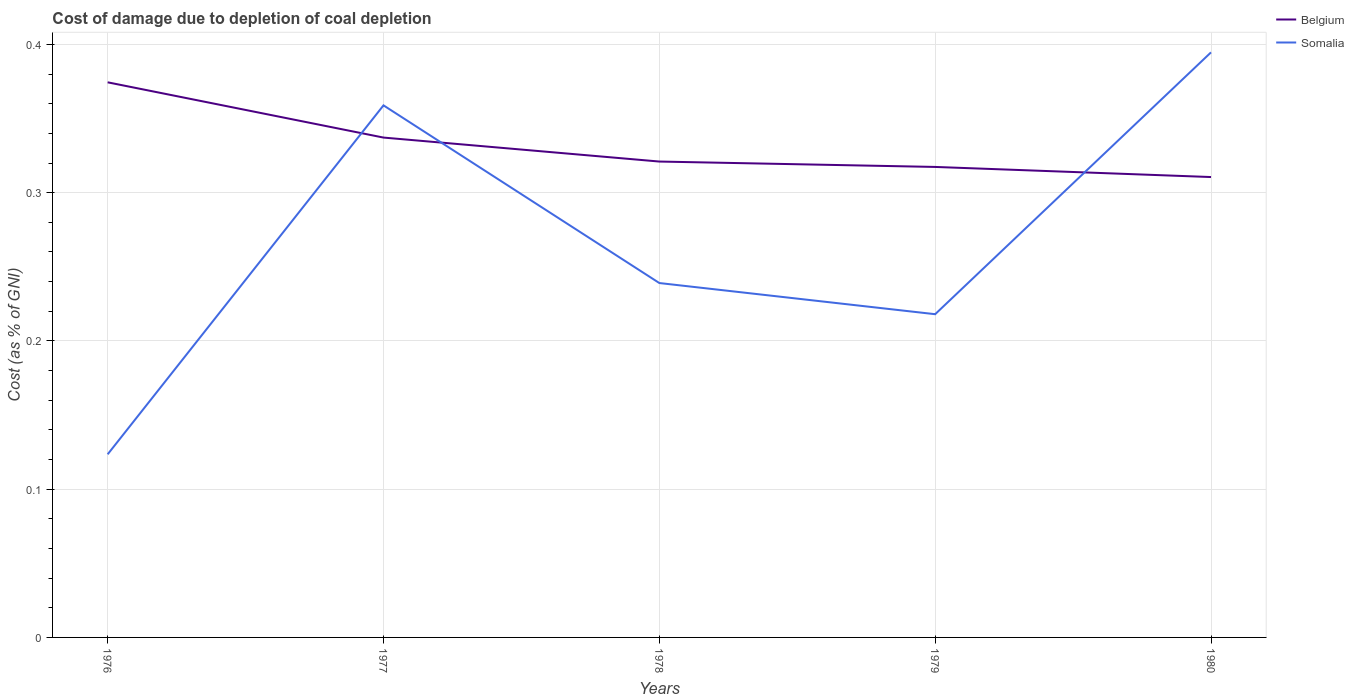Is the number of lines equal to the number of legend labels?
Offer a terse response. Yes. Across all years, what is the maximum cost of damage caused due to coal depletion in Belgium?
Provide a short and direct response. 0.31. In which year was the cost of damage caused due to coal depletion in Somalia maximum?
Your answer should be compact. 1976. What is the total cost of damage caused due to coal depletion in Belgium in the graph?
Give a very brief answer. 0. What is the difference between the highest and the second highest cost of damage caused due to coal depletion in Belgium?
Your response must be concise. 0.06. What is the difference between the highest and the lowest cost of damage caused due to coal depletion in Somalia?
Offer a very short reply. 2. How many lines are there?
Give a very brief answer. 2. What is the difference between two consecutive major ticks on the Y-axis?
Provide a short and direct response. 0.1. Does the graph contain grids?
Your response must be concise. Yes. How many legend labels are there?
Provide a short and direct response. 2. What is the title of the graph?
Your answer should be very brief. Cost of damage due to depletion of coal depletion. What is the label or title of the Y-axis?
Offer a very short reply. Cost (as % of GNI). What is the Cost (as % of GNI) of Belgium in 1976?
Provide a short and direct response. 0.37. What is the Cost (as % of GNI) of Somalia in 1976?
Give a very brief answer. 0.12. What is the Cost (as % of GNI) of Belgium in 1977?
Offer a very short reply. 0.34. What is the Cost (as % of GNI) of Somalia in 1977?
Your answer should be compact. 0.36. What is the Cost (as % of GNI) in Belgium in 1978?
Offer a very short reply. 0.32. What is the Cost (as % of GNI) in Somalia in 1978?
Give a very brief answer. 0.24. What is the Cost (as % of GNI) of Belgium in 1979?
Ensure brevity in your answer.  0.32. What is the Cost (as % of GNI) in Somalia in 1979?
Ensure brevity in your answer.  0.22. What is the Cost (as % of GNI) of Belgium in 1980?
Ensure brevity in your answer.  0.31. What is the Cost (as % of GNI) of Somalia in 1980?
Provide a short and direct response. 0.39. Across all years, what is the maximum Cost (as % of GNI) of Belgium?
Offer a very short reply. 0.37. Across all years, what is the maximum Cost (as % of GNI) of Somalia?
Offer a very short reply. 0.39. Across all years, what is the minimum Cost (as % of GNI) of Belgium?
Give a very brief answer. 0.31. Across all years, what is the minimum Cost (as % of GNI) of Somalia?
Offer a terse response. 0.12. What is the total Cost (as % of GNI) in Belgium in the graph?
Your answer should be compact. 1.66. What is the total Cost (as % of GNI) in Somalia in the graph?
Keep it short and to the point. 1.33. What is the difference between the Cost (as % of GNI) of Belgium in 1976 and that in 1977?
Your response must be concise. 0.04. What is the difference between the Cost (as % of GNI) of Somalia in 1976 and that in 1977?
Offer a terse response. -0.24. What is the difference between the Cost (as % of GNI) in Belgium in 1976 and that in 1978?
Provide a short and direct response. 0.05. What is the difference between the Cost (as % of GNI) of Somalia in 1976 and that in 1978?
Make the answer very short. -0.12. What is the difference between the Cost (as % of GNI) of Belgium in 1976 and that in 1979?
Give a very brief answer. 0.06. What is the difference between the Cost (as % of GNI) in Somalia in 1976 and that in 1979?
Give a very brief answer. -0.09. What is the difference between the Cost (as % of GNI) in Belgium in 1976 and that in 1980?
Your answer should be very brief. 0.06. What is the difference between the Cost (as % of GNI) of Somalia in 1976 and that in 1980?
Give a very brief answer. -0.27. What is the difference between the Cost (as % of GNI) in Belgium in 1977 and that in 1978?
Your answer should be compact. 0.02. What is the difference between the Cost (as % of GNI) in Somalia in 1977 and that in 1978?
Your answer should be very brief. 0.12. What is the difference between the Cost (as % of GNI) of Belgium in 1977 and that in 1979?
Ensure brevity in your answer.  0.02. What is the difference between the Cost (as % of GNI) of Somalia in 1977 and that in 1979?
Provide a short and direct response. 0.14. What is the difference between the Cost (as % of GNI) of Belgium in 1977 and that in 1980?
Offer a terse response. 0.03. What is the difference between the Cost (as % of GNI) of Somalia in 1977 and that in 1980?
Give a very brief answer. -0.04. What is the difference between the Cost (as % of GNI) in Belgium in 1978 and that in 1979?
Ensure brevity in your answer.  0. What is the difference between the Cost (as % of GNI) of Somalia in 1978 and that in 1979?
Your answer should be very brief. 0.02. What is the difference between the Cost (as % of GNI) of Belgium in 1978 and that in 1980?
Make the answer very short. 0.01. What is the difference between the Cost (as % of GNI) of Somalia in 1978 and that in 1980?
Your response must be concise. -0.16. What is the difference between the Cost (as % of GNI) in Belgium in 1979 and that in 1980?
Keep it short and to the point. 0.01. What is the difference between the Cost (as % of GNI) in Somalia in 1979 and that in 1980?
Make the answer very short. -0.18. What is the difference between the Cost (as % of GNI) of Belgium in 1976 and the Cost (as % of GNI) of Somalia in 1977?
Offer a terse response. 0.02. What is the difference between the Cost (as % of GNI) in Belgium in 1976 and the Cost (as % of GNI) in Somalia in 1978?
Ensure brevity in your answer.  0.14. What is the difference between the Cost (as % of GNI) of Belgium in 1976 and the Cost (as % of GNI) of Somalia in 1979?
Your response must be concise. 0.16. What is the difference between the Cost (as % of GNI) in Belgium in 1976 and the Cost (as % of GNI) in Somalia in 1980?
Your answer should be very brief. -0.02. What is the difference between the Cost (as % of GNI) of Belgium in 1977 and the Cost (as % of GNI) of Somalia in 1978?
Offer a terse response. 0.1. What is the difference between the Cost (as % of GNI) of Belgium in 1977 and the Cost (as % of GNI) of Somalia in 1979?
Offer a very short reply. 0.12. What is the difference between the Cost (as % of GNI) in Belgium in 1977 and the Cost (as % of GNI) in Somalia in 1980?
Offer a very short reply. -0.06. What is the difference between the Cost (as % of GNI) in Belgium in 1978 and the Cost (as % of GNI) in Somalia in 1979?
Offer a very short reply. 0.1. What is the difference between the Cost (as % of GNI) in Belgium in 1978 and the Cost (as % of GNI) in Somalia in 1980?
Offer a very short reply. -0.07. What is the difference between the Cost (as % of GNI) of Belgium in 1979 and the Cost (as % of GNI) of Somalia in 1980?
Your answer should be compact. -0.08. What is the average Cost (as % of GNI) in Belgium per year?
Keep it short and to the point. 0.33. What is the average Cost (as % of GNI) of Somalia per year?
Provide a short and direct response. 0.27. In the year 1976, what is the difference between the Cost (as % of GNI) of Belgium and Cost (as % of GNI) of Somalia?
Make the answer very short. 0.25. In the year 1977, what is the difference between the Cost (as % of GNI) of Belgium and Cost (as % of GNI) of Somalia?
Make the answer very short. -0.02. In the year 1978, what is the difference between the Cost (as % of GNI) in Belgium and Cost (as % of GNI) in Somalia?
Your answer should be very brief. 0.08. In the year 1979, what is the difference between the Cost (as % of GNI) of Belgium and Cost (as % of GNI) of Somalia?
Offer a terse response. 0.1. In the year 1980, what is the difference between the Cost (as % of GNI) in Belgium and Cost (as % of GNI) in Somalia?
Ensure brevity in your answer.  -0.08. What is the ratio of the Cost (as % of GNI) of Belgium in 1976 to that in 1977?
Your answer should be very brief. 1.11. What is the ratio of the Cost (as % of GNI) in Somalia in 1976 to that in 1977?
Provide a succinct answer. 0.34. What is the ratio of the Cost (as % of GNI) in Belgium in 1976 to that in 1978?
Your answer should be very brief. 1.17. What is the ratio of the Cost (as % of GNI) of Somalia in 1976 to that in 1978?
Ensure brevity in your answer.  0.52. What is the ratio of the Cost (as % of GNI) in Belgium in 1976 to that in 1979?
Give a very brief answer. 1.18. What is the ratio of the Cost (as % of GNI) of Somalia in 1976 to that in 1979?
Make the answer very short. 0.57. What is the ratio of the Cost (as % of GNI) in Belgium in 1976 to that in 1980?
Your response must be concise. 1.21. What is the ratio of the Cost (as % of GNI) in Somalia in 1976 to that in 1980?
Your answer should be very brief. 0.31. What is the ratio of the Cost (as % of GNI) in Belgium in 1977 to that in 1978?
Your answer should be very brief. 1.05. What is the ratio of the Cost (as % of GNI) in Somalia in 1977 to that in 1978?
Make the answer very short. 1.5. What is the ratio of the Cost (as % of GNI) in Belgium in 1977 to that in 1979?
Keep it short and to the point. 1.06. What is the ratio of the Cost (as % of GNI) in Somalia in 1977 to that in 1979?
Offer a terse response. 1.65. What is the ratio of the Cost (as % of GNI) of Belgium in 1977 to that in 1980?
Keep it short and to the point. 1.09. What is the ratio of the Cost (as % of GNI) in Somalia in 1977 to that in 1980?
Provide a short and direct response. 0.91. What is the ratio of the Cost (as % of GNI) of Belgium in 1978 to that in 1979?
Make the answer very short. 1.01. What is the ratio of the Cost (as % of GNI) of Somalia in 1978 to that in 1979?
Your answer should be very brief. 1.1. What is the ratio of the Cost (as % of GNI) of Belgium in 1978 to that in 1980?
Provide a succinct answer. 1.03. What is the ratio of the Cost (as % of GNI) of Somalia in 1978 to that in 1980?
Your answer should be compact. 0.61. What is the ratio of the Cost (as % of GNI) in Belgium in 1979 to that in 1980?
Provide a short and direct response. 1.02. What is the ratio of the Cost (as % of GNI) of Somalia in 1979 to that in 1980?
Your answer should be very brief. 0.55. What is the difference between the highest and the second highest Cost (as % of GNI) in Belgium?
Offer a very short reply. 0.04. What is the difference between the highest and the second highest Cost (as % of GNI) of Somalia?
Your answer should be compact. 0.04. What is the difference between the highest and the lowest Cost (as % of GNI) in Belgium?
Make the answer very short. 0.06. What is the difference between the highest and the lowest Cost (as % of GNI) of Somalia?
Your answer should be compact. 0.27. 